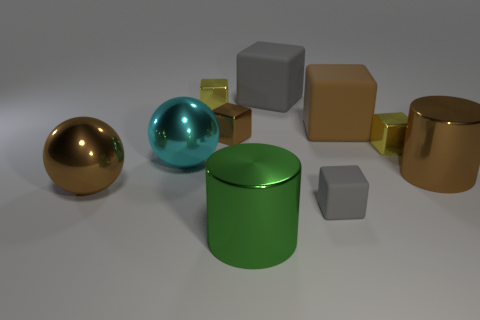Subtract all yellow cubes. How many cubes are left? 4 Subtract 1 cubes. How many cubes are left? 5 Subtract all brown blocks. How many blocks are left? 4 Subtract 0 red cubes. How many objects are left? 10 Subtract all spheres. How many objects are left? 8 Subtract all red cylinders. Subtract all brown blocks. How many cylinders are left? 2 Subtract all brown spheres. How many cyan blocks are left? 0 Subtract all large objects. Subtract all shiny spheres. How many objects are left? 2 Add 4 tiny gray cubes. How many tiny gray cubes are left? 5 Add 4 big brown shiny cylinders. How many big brown shiny cylinders exist? 5 